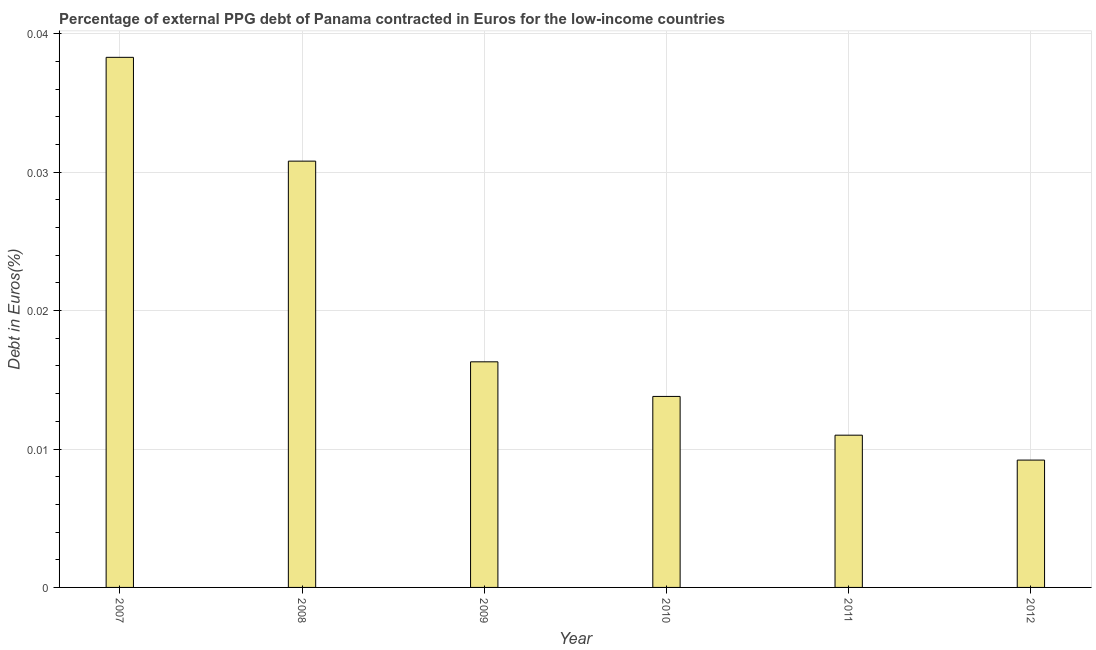Does the graph contain grids?
Your response must be concise. Yes. What is the title of the graph?
Your response must be concise. Percentage of external PPG debt of Panama contracted in Euros for the low-income countries. What is the label or title of the X-axis?
Offer a terse response. Year. What is the label or title of the Y-axis?
Your response must be concise. Debt in Euros(%). What is the currency composition of ppg debt in 2009?
Provide a short and direct response. 0.02. Across all years, what is the maximum currency composition of ppg debt?
Provide a short and direct response. 0.04. Across all years, what is the minimum currency composition of ppg debt?
Your answer should be compact. 0.01. In which year was the currency composition of ppg debt maximum?
Make the answer very short. 2007. What is the sum of the currency composition of ppg debt?
Provide a succinct answer. 0.12. What is the difference between the currency composition of ppg debt in 2011 and 2012?
Your response must be concise. 0. What is the average currency composition of ppg debt per year?
Offer a terse response. 0.02. What is the median currency composition of ppg debt?
Provide a succinct answer. 0.02. In how many years, is the currency composition of ppg debt greater than 0.02 %?
Give a very brief answer. 2. Do a majority of the years between 2007 and 2012 (inclusive) have currency composition of ppg debt greater than 0.02 %?
Keep it short and to the point. No. What is the ratio of the currency composition of ppg debt in 2008 to that in 2010?
Keep it short and to the point. 2.23. Is the currency composition of ppg debt in 2009 less than that in 2011?
Ensure brevity in your answer.  No. What is the difference between the highest and the second highest currency composition of ppg debt?
Your answer should be compact. 0.01. Is the sum of the currency composition of ppg debt in 2007 and 2010 greater than the maximum currency composition of ppg debt across all years?
Provide a succinct answer. Yes. What is the difference between the highest and the lowest currency composition of ppg debt?
Give a very brief answer. 0.03. In how many years, is the currency composition of ppg debt greater than the average currency composition of ppg debt taken over all years?
Give a very brief answer. 2. Are all the bars in the graph horizontal?
Your answer should be very brief. No. How many years are there in the graph?
Give a very brief answer. 6. What is the Debt in Euros(%) in 2007?
Offer a very short reply. 0.04. What is the Debt in Euros(%) of 2008?
Ensure brevity in your answer.  0.03. What is the Debt in Euros(%) of 2009?
Ensure brevity in your answer.  0.02. What is the Debt in Euros(%) of 2010?
Provide a succinct answer. 0.01. What is the Debt in Euros(%) in 2011?
Offer a very short reply. 0.01. What is the Debt in Euros(%) in 2012?
Give a very brief answer. 0.01. What is the difference between the Debt in Euros(%) in 2007 and 2008?
Make the answer very short. 0.01. What is the difference between the Debt in Euros(%) in 2007 and 2009?
Provide a short and direct response. 0.02. What is the difference between the Debt in Euros(%) in 2007 and 2010?
Keep it short and to the point. 0.02. What is the difference between the Debt in Euros(%) in 2007 and 2011?
Give a very brief answer. 0.03. What is the difference between the Debt in Euros(%) in 2007 and 2012?
Keep it short and to the point. 0.03. What is the difference between the Debt in Euros(%) in 2008 and 2009?
Your response must be concise. 0.01. What is the difference between the Debt in Euros(%) in 2008 and 2010?
Your answer should be compact. 0.02. What is the difference between the Debt in Euros(%) in 2008 and 2011?
Provide a succinct answer. 0.02. What is the difference between the Debt in Euros(%) in 2008 and 2012?
Make the answer very short. 0.02. What is the difference between the Debt in Euros(%) in 2009 and 2010?
Offer a terse response. 0. What is the difference between the Debt in Euros(%) in 2009 and 2011?
Ensure brevity in your answer.  0.01. What is the difference between the Debt in Euros(%) in 2009 and 2012?
Keep it short and to the point. 0.01. What is the difference between the Debt in Euros(%) in 2010 and 2011?
Your response must be concise. 0. What is the difference between the Debt in Euros(%) in 2010 and 2012?
Offer a terse response. 0. What is the difference between the Debt in Euros(%) in 2011 and 2012?
Make the answer very short. 0. What is the ratio of the Debt in Euros(%) in 2007 to that in 2008?
Provide a succinct answer. 1.24. What is the ratio of the Debt in Euros(%) in 2007 to that in 2009?
Offer a very short reply. 2.35. What is the ratio of the Debt in Euros(%) in 2007 to that in 2010?
Provide a short and direct response. 2.77. What is the ratio of the Debt in Euros(%) in 2007 to that in 2011?
Your answer should be very brief. 3.48. What is the ratio of the Debt in Euros(%) in 2007 to that in 2012?
Provide a short and direct response. 4.16. What is the ratio of the Debt in Euros(%) in 2008 to that in 2009?
Offer a terse response. 1.89. What is the ratio of the Debt in Euros(%) in 2008 to that in 2010?
Give a very brief answer. 2.23. What is the ratio of the Debt in Euros(%) in 2008 to that in 2012?
Keep it short and to the point. 3.35. What is the ratio of the Debt in Euros(%) in 2009 to that in 2010?
Provide a succinct answer. 1.18. What is the ratio of the Debt in Euros(%) in 2009 to that in 2011?
Make the answer very short. 1.48. What is the ratio of the Debt in Euros(%) in 2009 to that in 2012?
Provide a short and direct response. 1.77. What is the ratio of the Debt in Euros(%) in 2010 to that in 2011?
Your answer should be very brief. 1.25. What is the ratio of the Debt in Euros(%) in 2011 to that in 2012?
Provide a short and direct response. 1.2. 